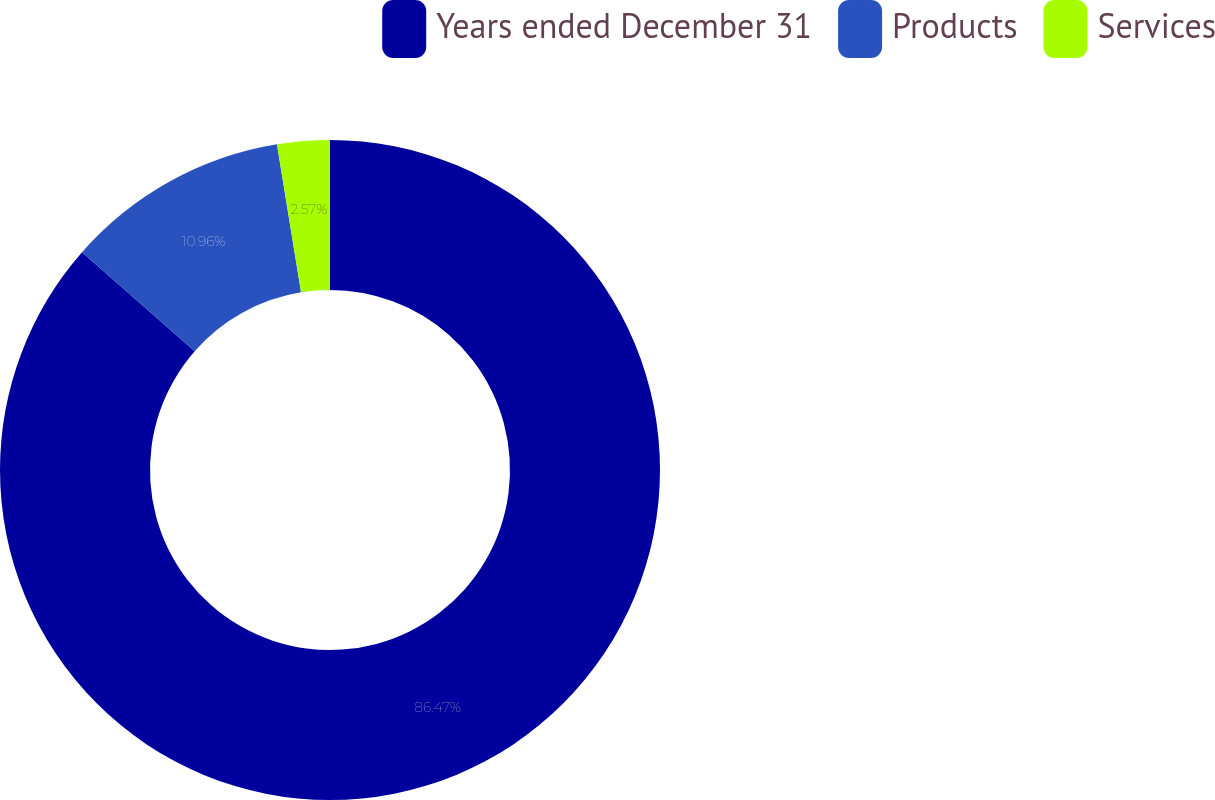Convert chart to OTSL. <chart><loc_0><loc_0><loc_500><loc_500><pie_chart><fcel>Years ended December 31<fcel>Products<fcel>Services<nl><fcel>86.46%<fcel>10.96%<fcel>2.57%<nl></chart> 